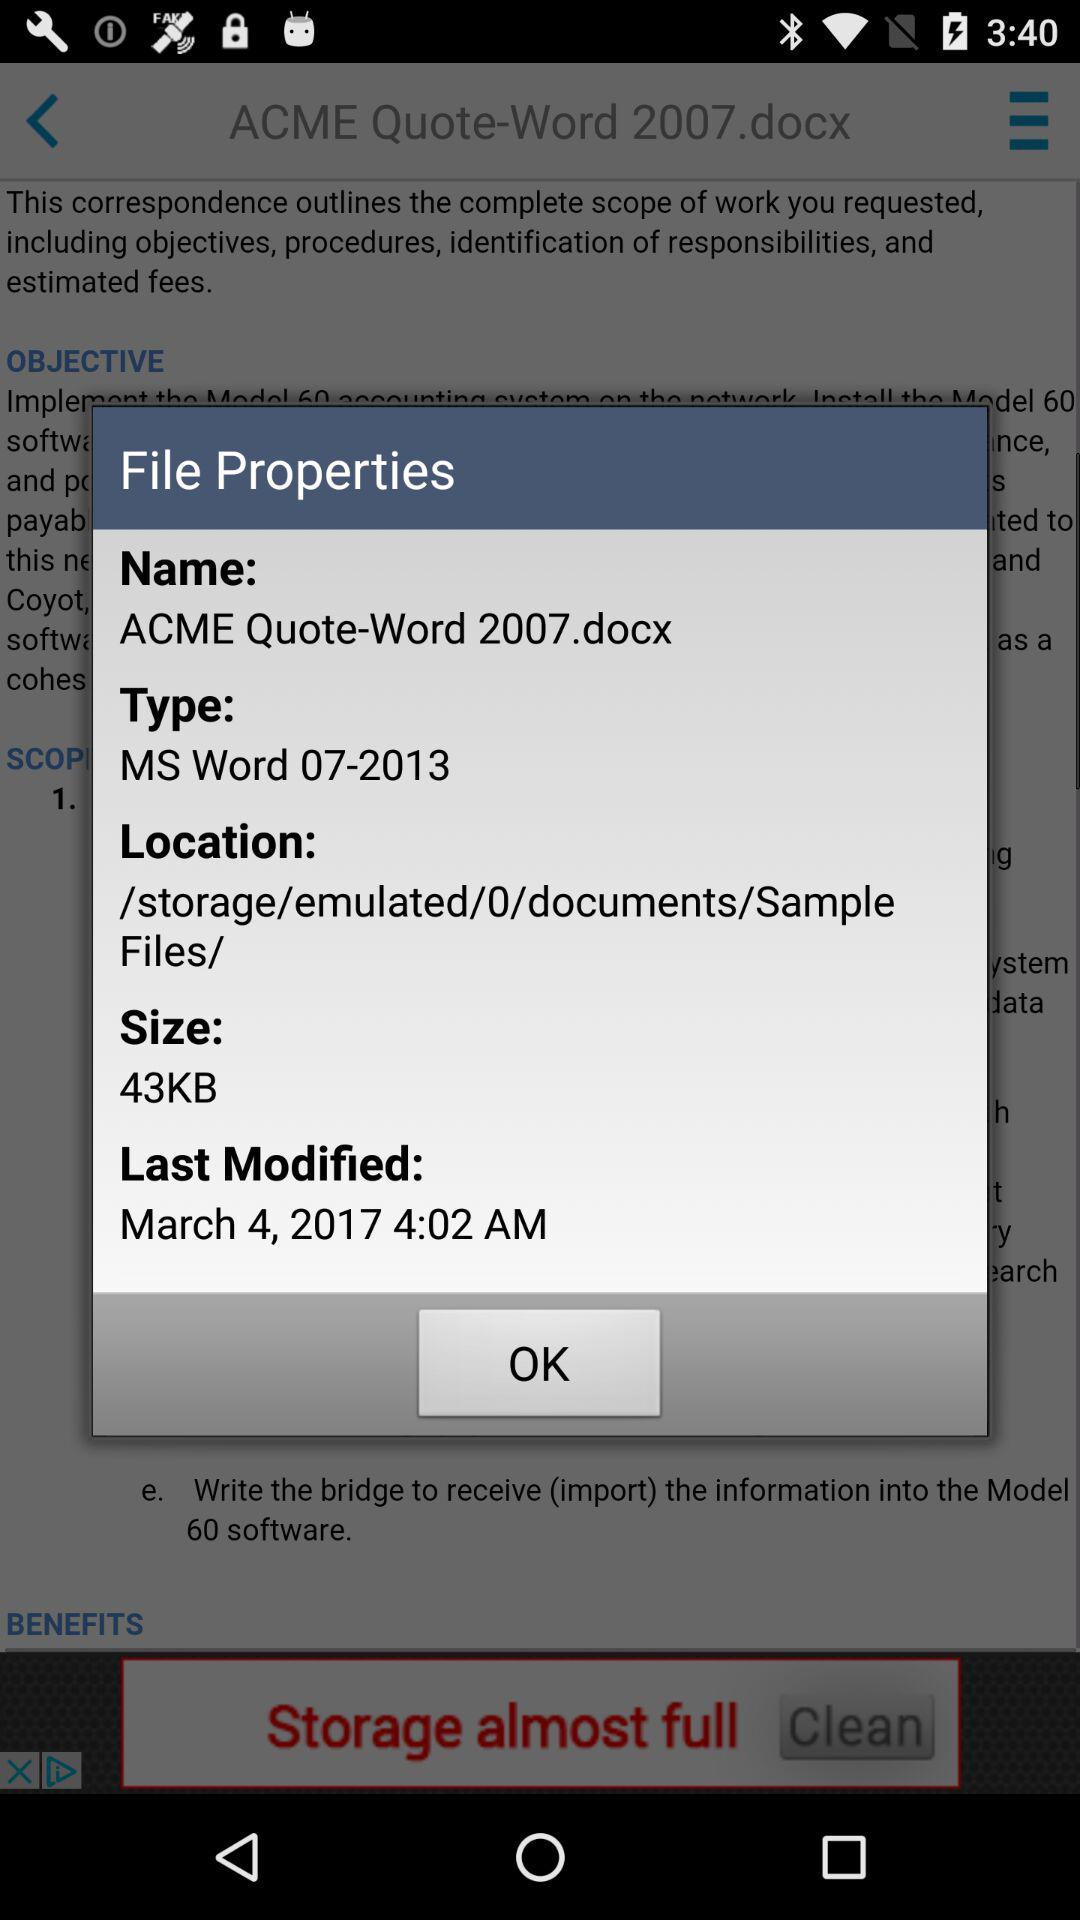What is a file type? The file type is MS Word 07-2013. 